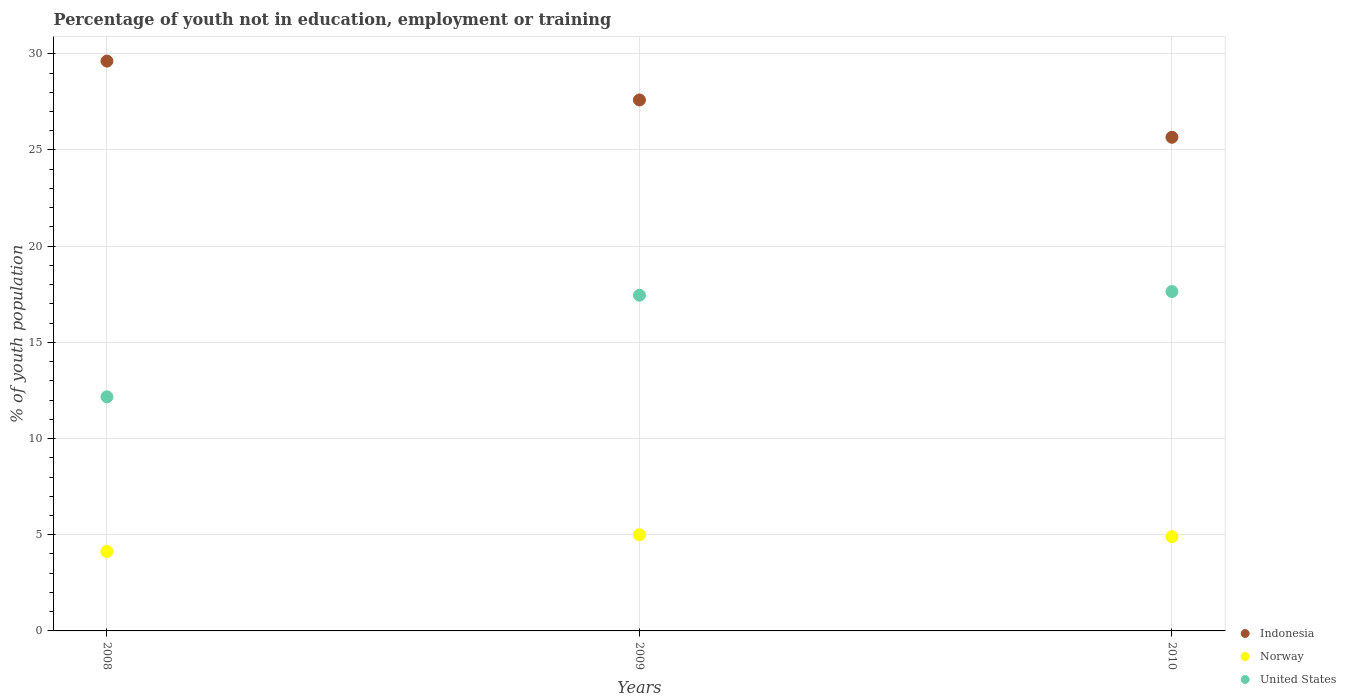Is the number of dotlines equal to the number of legend labels?
Your answer should be very brief. Yes. What is the percentage of unemployed youth population in in Indonesia in 2008?
Keep it short and to the point. 29.62. Across all years, what is the maximum percentage of unemployed youth population in in Indonesia?
Give a very brief answer. 29.62. Across all years, what is the minimum percentage of unemployed youth population in in Indonesia?
Offer a terse response. 25.66. In which year was the percentage of unemployed youth population in in Indonesia maximum?
Provide a succinct answer. 2008. In which year was the percentage of unemployed youth population in in Norway minimum?
Your response must be concise. 2008. What is the total percentage of unemployed youth population in in Indonesia in the graph?
Offer a very short reply. 82.88. What is the difference between the percentage of unemployed youth population in in Norway in 2008 and that in 2010?
Ensure brevity in your answer.  -0.77. What is the difference between the percentage of unemployed youth population in in Norway in 2009 and the percentage of unemployed youth population in in Indonesia in 2008?
Ensure brevity in your answer.  -24.62. What is the average percentage of unemployed youth population in in United States per year?
Make the answer very short. 15.75. In the year 2009, what is the difference between the percentage of unemployed youth population in in United States and percentage of unemployed youth population in in Norway?
Your response must be concise. 12.45. What is the ratio of the percentage of unemployed youth population in in Norway in 2009 to that in 2010?
Your response must be concise. 1.02. What is the difference between the highest and the second highest percentage of unemployed youth population in in Indonesia?
Your response must be concise. 2.02. What is the difference between the highest and the lowest percentage of unemployed youth population in in United States?
Offer a terse response. 5.47. Is the sum of the percentage of unemployed youth population in in United States in 2008 and 2010 greater than the maximum percentage of unemployed youth population in in Norway across all years?
Make the answer very short. Yes. Does the percentage of unemployed youth population in in Indonesia monotonically increase over the years?
Provide a short and direct response. No. Is the percentage of unemployed youth population in in United States strictly less than the percentage of unemployed youth population in in Indonesia over the years?
Ensure brevity in your answer.  Yes. How many dotlines are there?
Keep it short and to the point. 3. How many years are there in the graph?
Your answer should be compact. 3. Are the values on the major ticks of Y-axis written in scientific E-notation?
Provide a succinct answer. No. Does the graph contain any zero values?
Offer a terse response. No. Does the graph contain grids?
Keep it short and to the point. Yes. Where does the legend appear in the graph?
Offer a very short reply. Bottom right. How are the legend labels stacked?
Ensure brevity in your answer.  Vertical. What is the title of the graph?
Your answer should be compact. Percentage of youth not in education, employment or training. Does "Seychelles" appear as one of the legend labels in the graph?
Give a very brief answer. No. What is the label or title of the Y-axis?
Offer a terse response. % of youth population. What is the % of youth population in Indonesia in 2008?
Provide a short and direct response. 29.62. What is the % of youth population of Norway in 2008?
Make the answer very short. 4.13. What is the % of youth population of United States in 2008?
Your response must be concise. 12.17. What is the % of youth population of Indonesia in 2009?
Your answer should be compact. 27.6. What is the % of youth population of Norway in 2009?
Make the answer very short. 5. What is the % of youth population of United States in 2009?
Provide a short and direct response. 17.45. What is the % of youth population of Indonesia in 2010?
Your answer should be very brief. 25.66. What is the % of youth population in Norway in 2010?
Your answer should be compact. 4.9. What is the % of youth population in United States in 2010?
Your answer should be very brief. 17.64. Across all years, what is the maximum % of youth population in Indonesia?
Provide a short and direct response. 29.62. Across all years, what is the maximum % of youth population in United States?
Your answer should be very brief. 17.64. Across all years, what is the minimum % of youth population in Indonesia?
Your response must be concise. 25.66. Across all years, what is the minimum % of youth population in Norway?
Give a very brief answer. 4.13. Across all years, what is the minimum % of youth population in United States?
Keep it short and to the point. 12.17. What is the total % of youth population in Indonesia in the graph?
Your answer should be very brief. 82.88. What is the total % of youth population of Norway in the graph?
Give a very brief answer. 14.03. What is the total % of youth population of United States in the graph?
Provide a succinct answer. 47.26. What is the difference between the % of youth population in Indonesia in 2008 and that in 2009?
Offer a very short reply. 2.02. What is the difference between the % of youth population of Norway in 2008 and that in 2009?
Provide a succinct answer. -0.87. What is the difference between the % of youth population in United States in 2008 and that in 2009?
Offer a very short reply. -5.28. What is the difference between the % of youth population in Indonesia in 2008 and that in 2010?
Your answer should be very brief. 3.96. What is the difference between the % of youth population of Norway in 2008 and that in 2010?
Ensure brevity in your answer.  -0.77. What is the difference between the % of youth population in United States in 2008 and that in 2010?
Your answer should be compact. -5.47. What is the difference between the % of youth population of Indonesia in 2009 and that in 2010?
Your answer should be compact. 1.94. What is the difference between the % of youth population in United States in 2009 and that in 2010?
Provide a succinct answer. -0.19. What is the difference between the % of youth population of Indonesia in 2008 and the % of youth population of Norway in 2009?
Your answer should be very brief. 24.62. What is the difference between the % of youth population of Indonesia in 2008 and the % of youth population of United States in 2009?
Provide a succinct answer. 12.17. What is the difference between the % of youth population of Norway in 2008 and the % of youth population of United States in 2009?
Offer a very short reply. -13.32. What is the difference between the % of youth population of Indonesia in 2008 and the % of youth population of Norway in 2010?
Your response must be concise. 24.72. What is the difference between the % of youth population of Indonesia in 2008 and the % of youth population of United States in 2010?
Keep it short and to the point. 11.98. What is the difference between the % of youth population of Norway in 2008 and the % of youth population of United States in 2010?
Provide a short and direct response. -13.51. What is the difference between the % of youth population in Indonesia in 2009 and the % of youth population in Norway in 2010?
Your answer should be compact. 22.7. What is the difference between the % of youth population of Indonesia in 2009 and the % of youth population of United States in 2010?
Give a very brief answer. 9.96. What is the difference between the % of youth population in Norway in 2009 and the % of youth population in United States in 2010?
Offer a terse response. -12.64. What is the average % of youth population of Indonesia per year?
Provide a succinct answer. 27.63. What is the average % of youth population in Norway per year?
Keep it short and to the point. 4.68. What is the average % of youth population in United States per year?
Offer a terse response. 15.75. In the year 2008, what is the difference between the % of youth population in Indonesia and % of youth population in Norway?
Provide a succinct answer. 25.49. In the year 2008, what is the difference between the % of youth population in Indonesia and % of youth population in United States?
Provide a succinct answer. 17.45. In the year 2008, what is the difference between the % of youth population in Norway and % of youth population in United States?
Ensure brevity in your answer.  -8.04. In the year 2009, what is the difference between the % of youth population of Indonesia and % of youth population of Norway?
Offer a terse response. 22.6. In the year 2009, what is the difference between the % of youth population in Indonesia and % of youth population in United States?
Give a very brief answer. 10.15. In the year 2009, what is the difference between the % of youth population of Norway and % of youth population of United States?
Your answer should be compact. -12.45. In the year 2010, what is the difference between the % of youth population in Indonesia and % of youth population in Norway?
Offer a very short reply. 20.76. In the year 2010, what is the difference between the % of youth population of Indonesia and % of youth population of United States?
Ensure brevity in your answer.  8.02. In the year 2010, what is the difference between the % of youth population of Norway and % of youth population of United States?
Your answer should be very brief. -12.74. What is the ratio of the % of youth population of Indonesia in 2008 to that in 2009?
Provide a short and direct response. 1.07. What is the ratio of the % of youth population of Norway in 2008 to that in 2009?
Offer a very short reply. 0.83. What is the ratio of the % of youth population of United States in 2008 to that in 2009?
Provide a succinct answer. 0.7. What is the ratio of the % of youth population of Indonesia in 2008 to that in 2010?
Offer a terse response. 1.15. What is the ratio of the % of youth population in Norway in 2008 to that in 2010?
Provide a succinct answer. 0.84. What is the ratio of the % of youth population in United States in 2008 to that in 2010?
Make the answer very short. 0.69. What is the ratio of the % of youth population of Indonesia in 2009 to that in 2010?
Ensure brevity in your answer.  1.08. What is the ratio of the % of youth population of Norway in 2009 to that in 2010?
Ensure brevity in your answer.  1.02. What is the ratio of the % of youth population in United States in 2009 to that in 2010?
Offer a very short reply. 0.99. What is the difference between the highest and the second highest % of youth population of Indonesia?
Offer a terse response. 2.02. What is the difference between the highest and the second highest % of youth population in United States?
Offer a very short reply. 0.19. What is the difference between the highest and the lowest % of youth population in Indonesia?
Your response must be concise. 3.96. What is the difference between the highest and the lowest % of youth population in Norway?
Keep it short and to the point. 0.87. What is the difference between the highest and the lowest % of youth population in United States?
Provide a succinct answer. 5.47. 